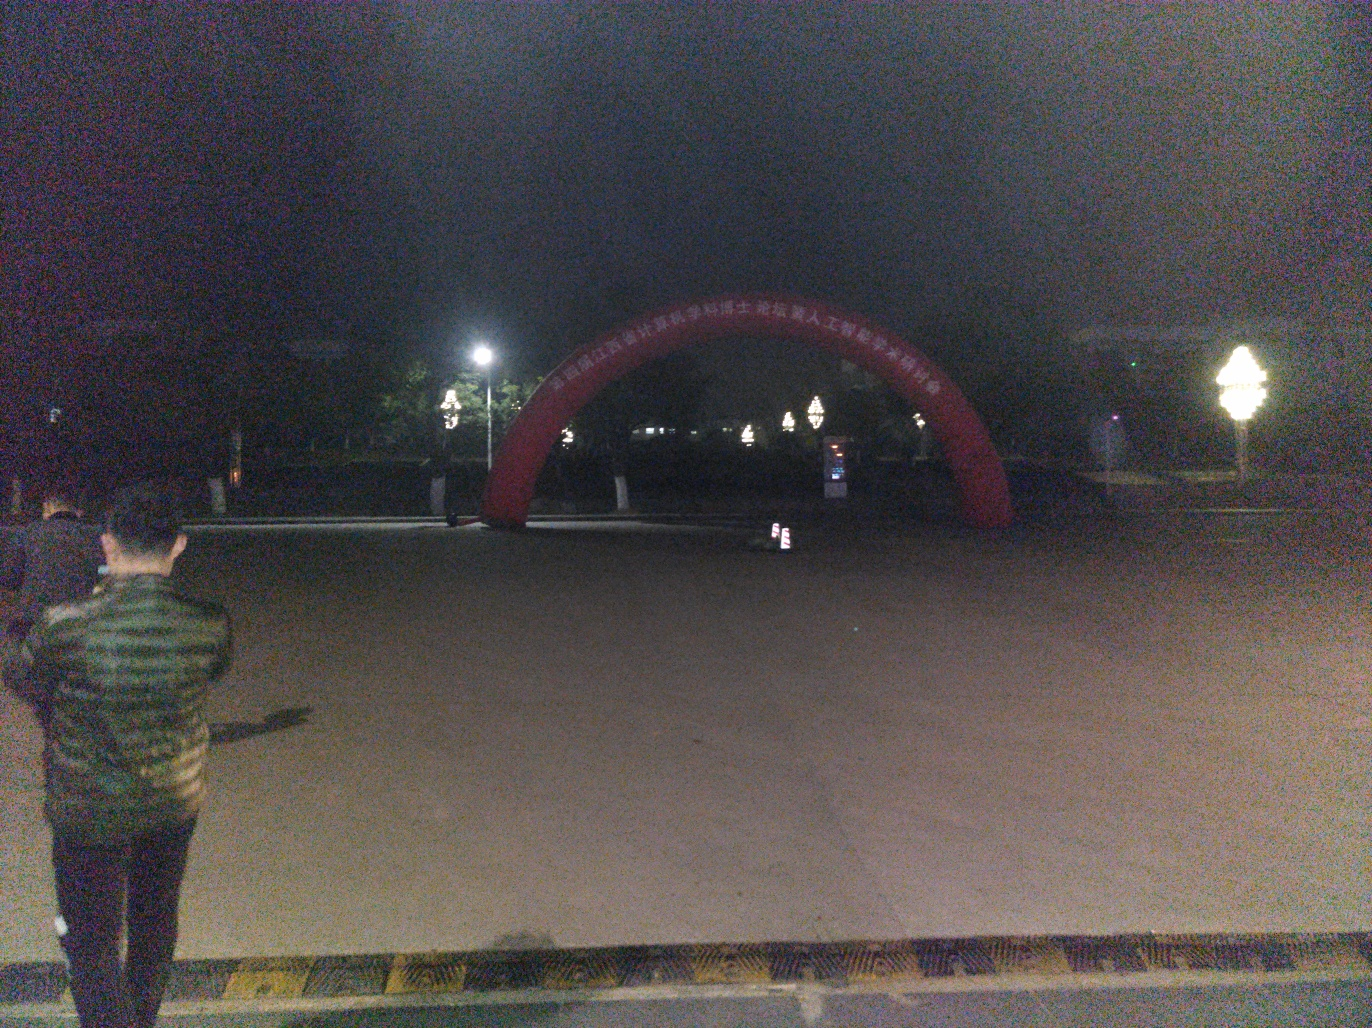What time of day does this picture seem to have been taken? Given the dark sky and artificial lighting from the lamps and the electronic device in the foreground, it seems reasonable to assume that the picture was taken at night. The absence of natural light suggests it's well after sunset. 